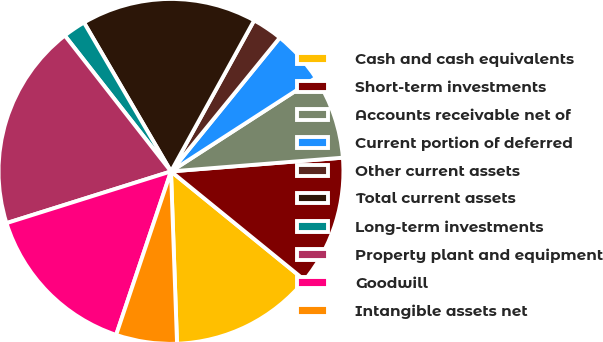Convert chart to OTSL. <chart><loc_0><loc_0><loc_500><loc_500><pie_chart><fcel>Cash and cash equivalents<fcel>Short-term investments<fcel>Accounts receivable net of<fcel>Current portion of deferred<fcel>Other current assets<fcel>Total current assets<fcel>Long-term investments<fcel>Property plant and equipment<fcel>Goodwill<fcel>Intangible assets net<nl><fcel>13.57%<fcel>12.14%<fcel>7.86%<fcel>5.0%<fcel>2.86%<fcel>16.43%<fcel>2.14%<fcel>19.29%<fcel>15.0%<fcel>5.71%<nl></chart> 